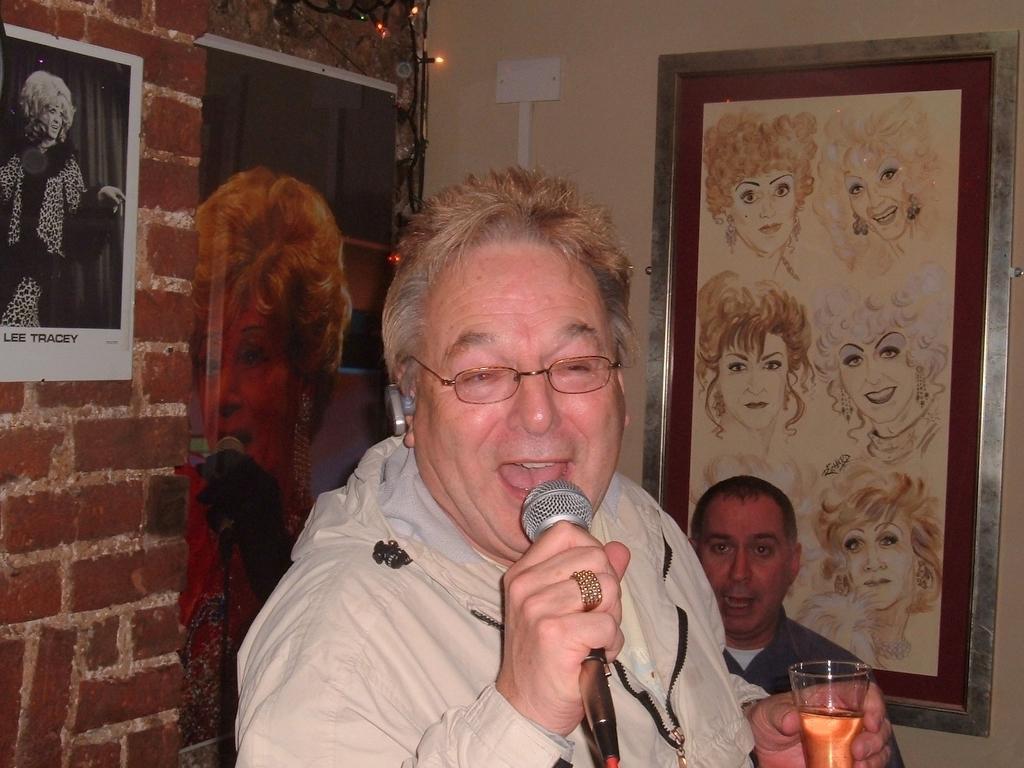Can you describe this image briefly? This person standing holding microphone ,glass and talking wear glasses,behind this person we can see wall,frame,poster,there is a person ,screen in this screen there is a woman holding microphone. 